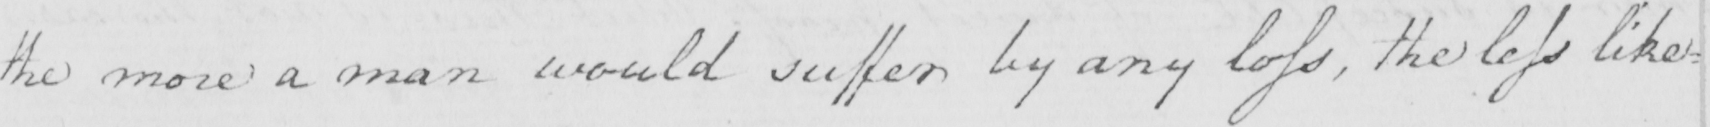Please transcribe the handwritten text in this image. the more a man would suffer by any loss  , the less like= 